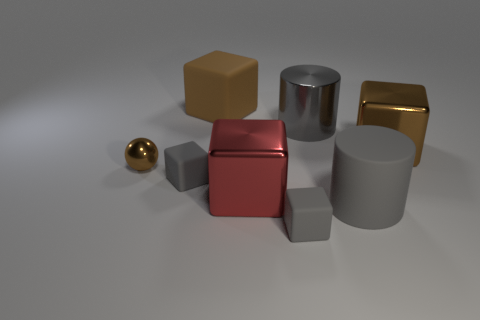How many red objects are there? There is one red object in the image, which is a shiny red cube situated roughly at the center among other geometric shapes. 